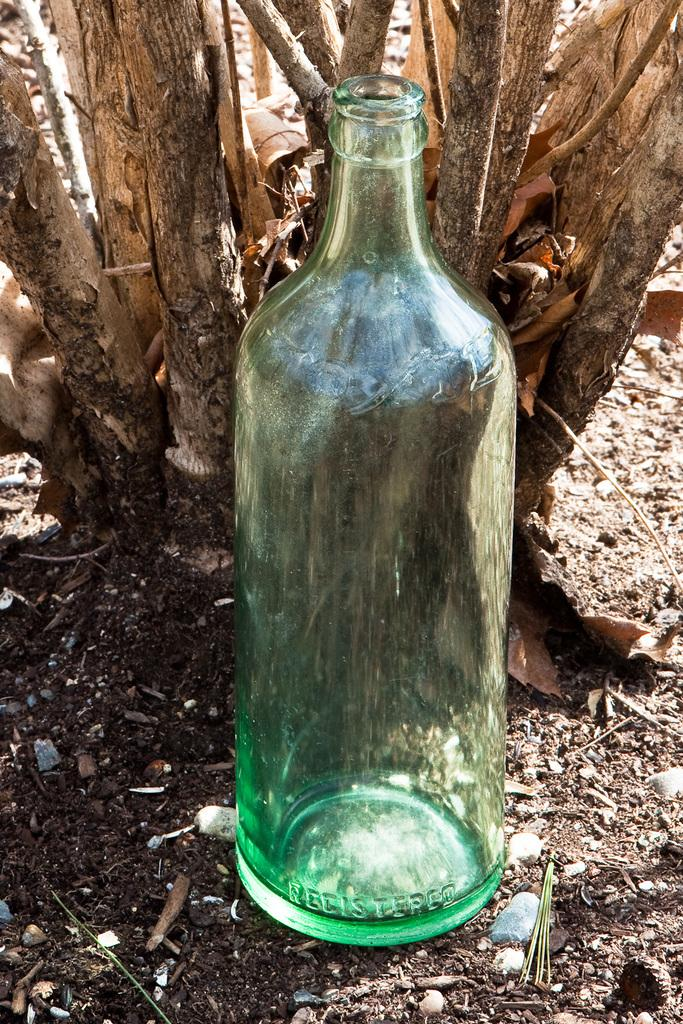What object is placed on the ground in the image? There is a glass bottle placed on the ground in the image. What can be seen in the background of the image? There is a tree visible in the background of the image. What type of grain is growing around the glass bottle in the image? There is no grain visible in the image; it only features a glass bottle placed on the ground and a tree in the background. 